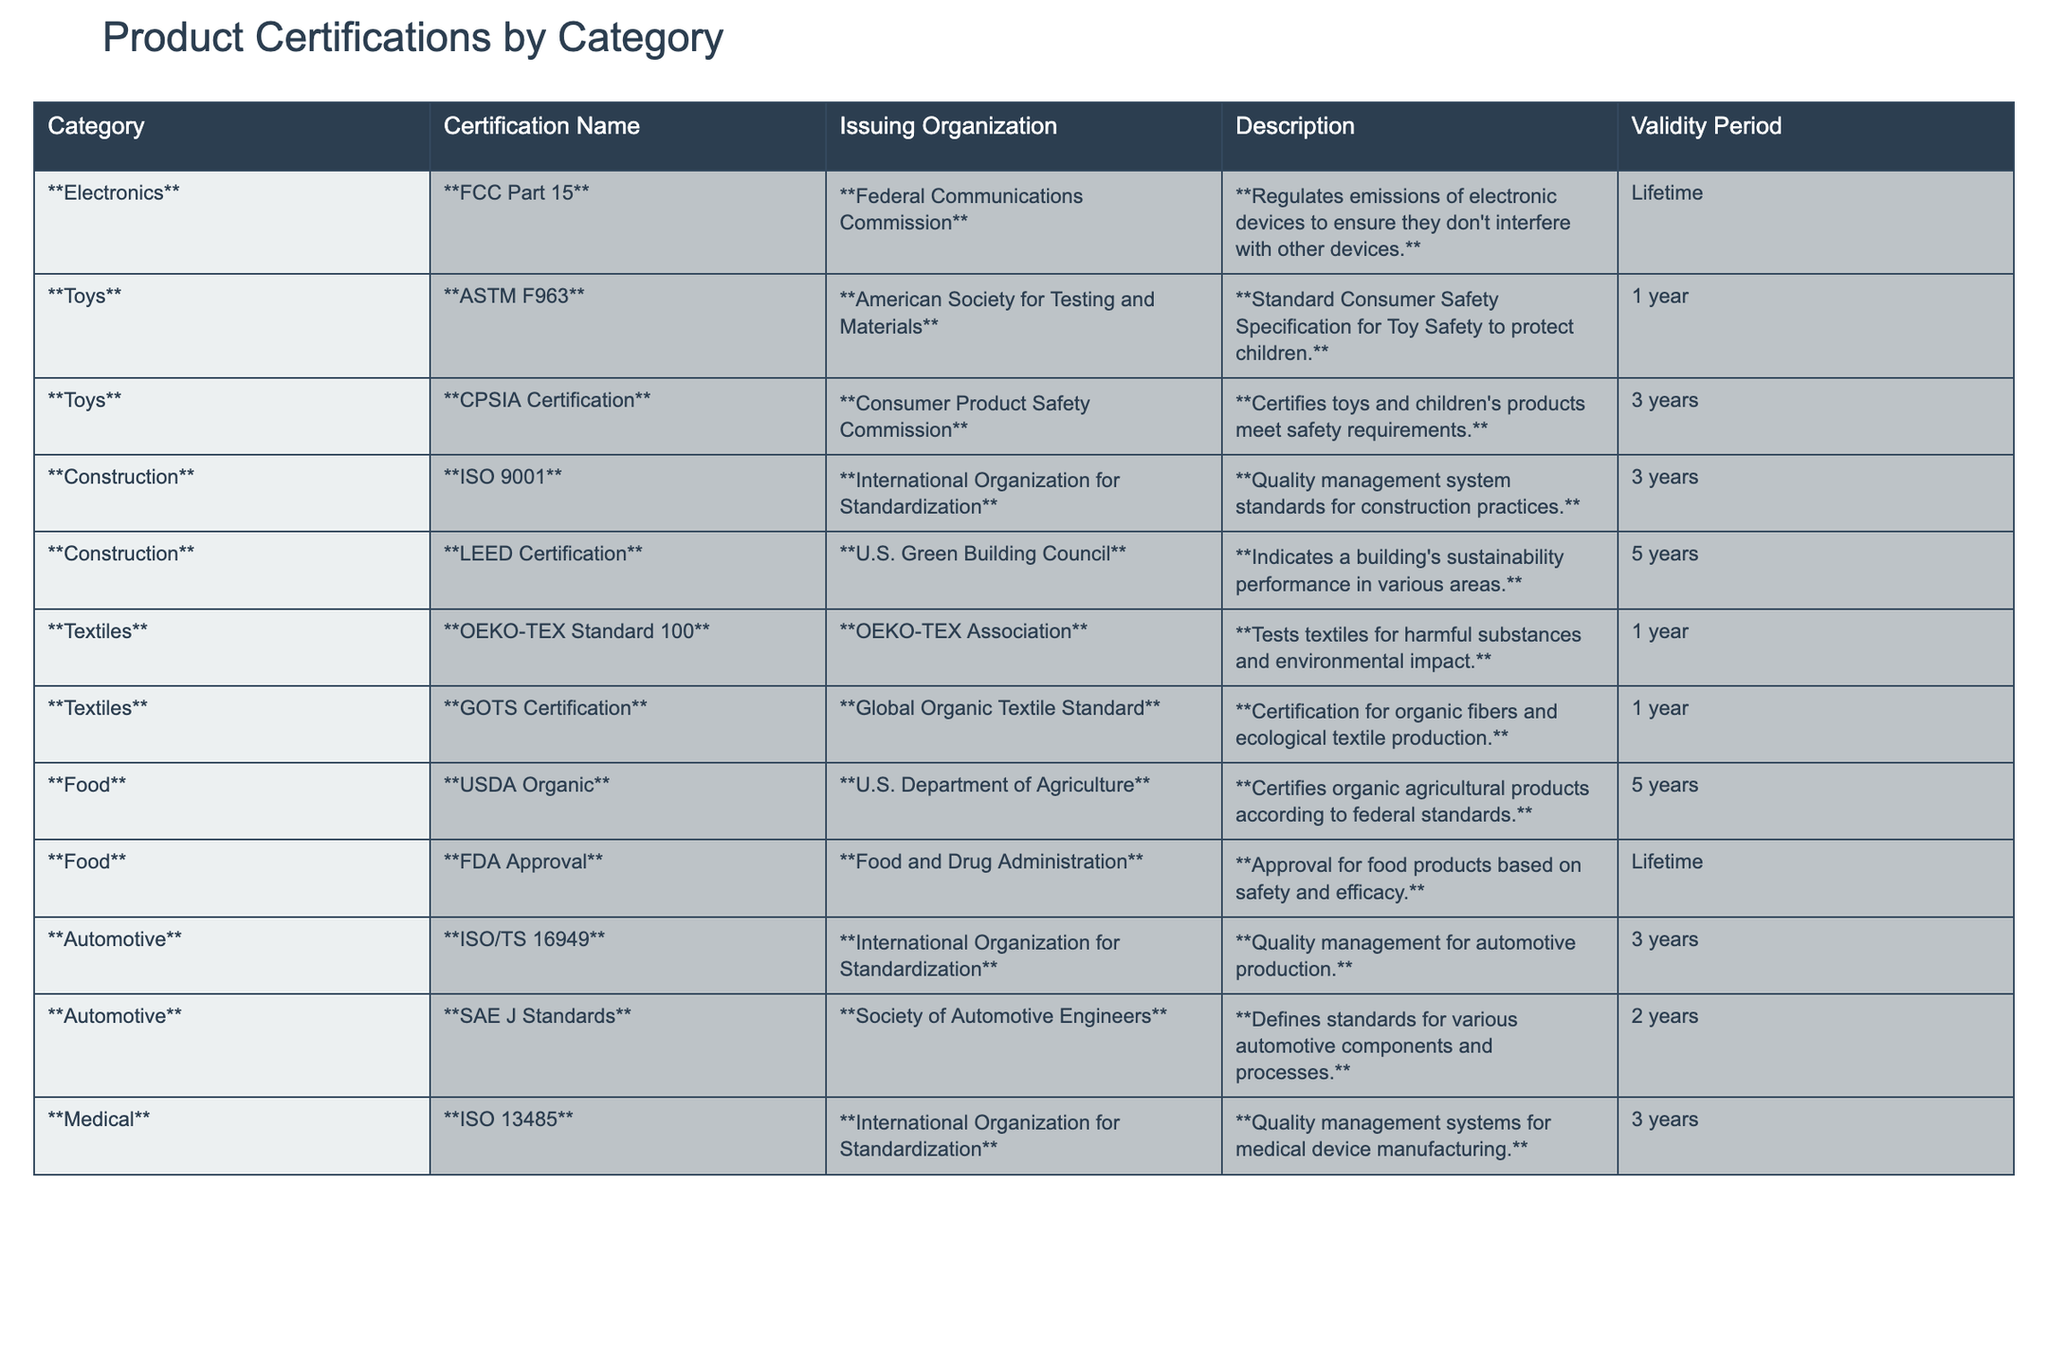What is the validity period of the USDA Organic certification? The USDA Organic certification has a validity period listed in the table, which shows it as "5 years."
Answer: 5 years Which category has the longest validity period for certifications? Looking at the validity periods for each category, LEED Certification has a validity period of "5 years," which is the longest compared to others, like FCC Part 15 and FDA Approval, which are "Lifetime."
Answer: 5 years Does the ISO 13485 certification apply to electronics? The ISO 13485 certification is specifically listed under the Medical category, indicating it does not apply to electronics.
Answer: No How many certifications in the Toys category have a validity of 1 year? There are two certifications in the Toys category: ASTM F963 and GOTS Certification. Both certifications have a validity period of "1 year."
Answer: 2 Which automotive certification has the shortest validity period? The table shows two automotive certifications: ISO/TS 16949 with a validity of "3 years" and SAE J Standards with a validity of "2 years." Hence, SAE J Standards has the shortest period.
Answer: 2 years Are any certifications in the Textiles category valid for more than 1 year? The table indicates that the certifications in the Textiles category—OEKO-TEX Standard 100 and GOTS Certification—are both valid for only "1 year." Therefore, no certifications exceed this duration.
Answer: No What is the average validity period for the certifications listed under Construction? The Construction category includes ISO 9001 (3 years) and LEED Certification (5 years). The average validity can be calculated: (3 + 5)/2 = 4 years, hence the average is 4 years.
Answer: 4 years Which issuing organization is responsible for both the ISO 9001 and ISO/TS 16949 certifications? Upon examining the issuing organizations for the certifications, both ISO 9001 and ISO/TS 16949 are issued by the International Organization for Standardization.
Answer: International Organization for Standardization How many total certifications are referenced in the Food category of the table? The Food category features a total of two certifications: USDA Organic and FDA Approval. Therefore, the total count for the Food category is 2.
Answer: 2 Is the validity period for the FDA Approval certification longer than that for CPSIA Certification? The FDA Approval certification is valid for "Lifetime," while the CPSIA Certification is valid for "3 years." Since "Lifetime" surpasses "3 years," the answer is affirmative.
Answer: Yes 